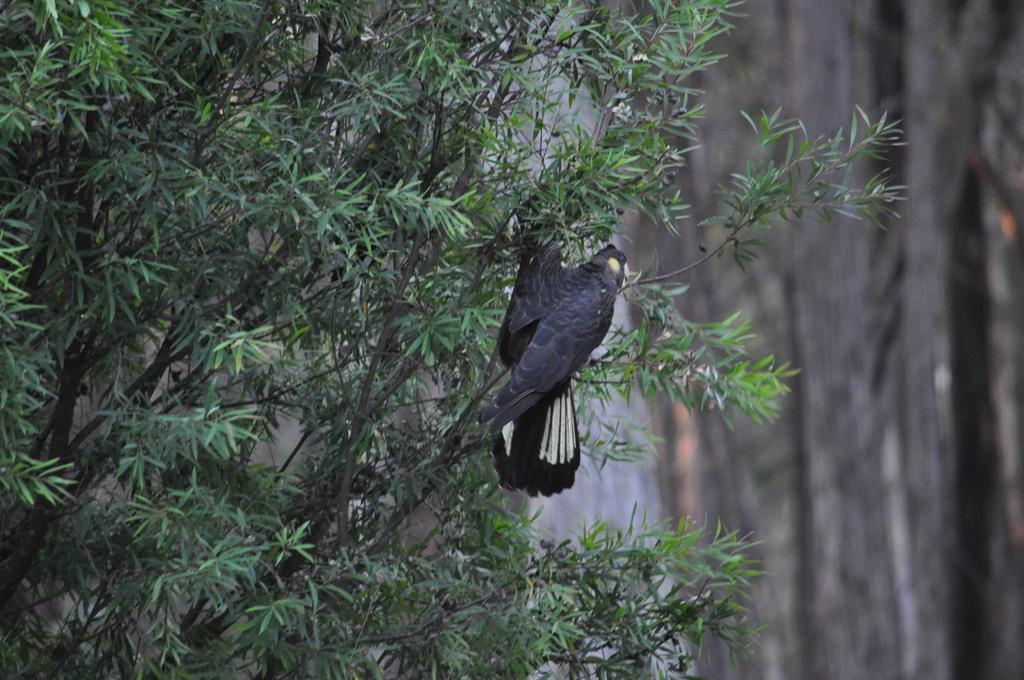Can you describe this image briefly? In the image there is a tree and a bird is laying on the branch of the tree. 